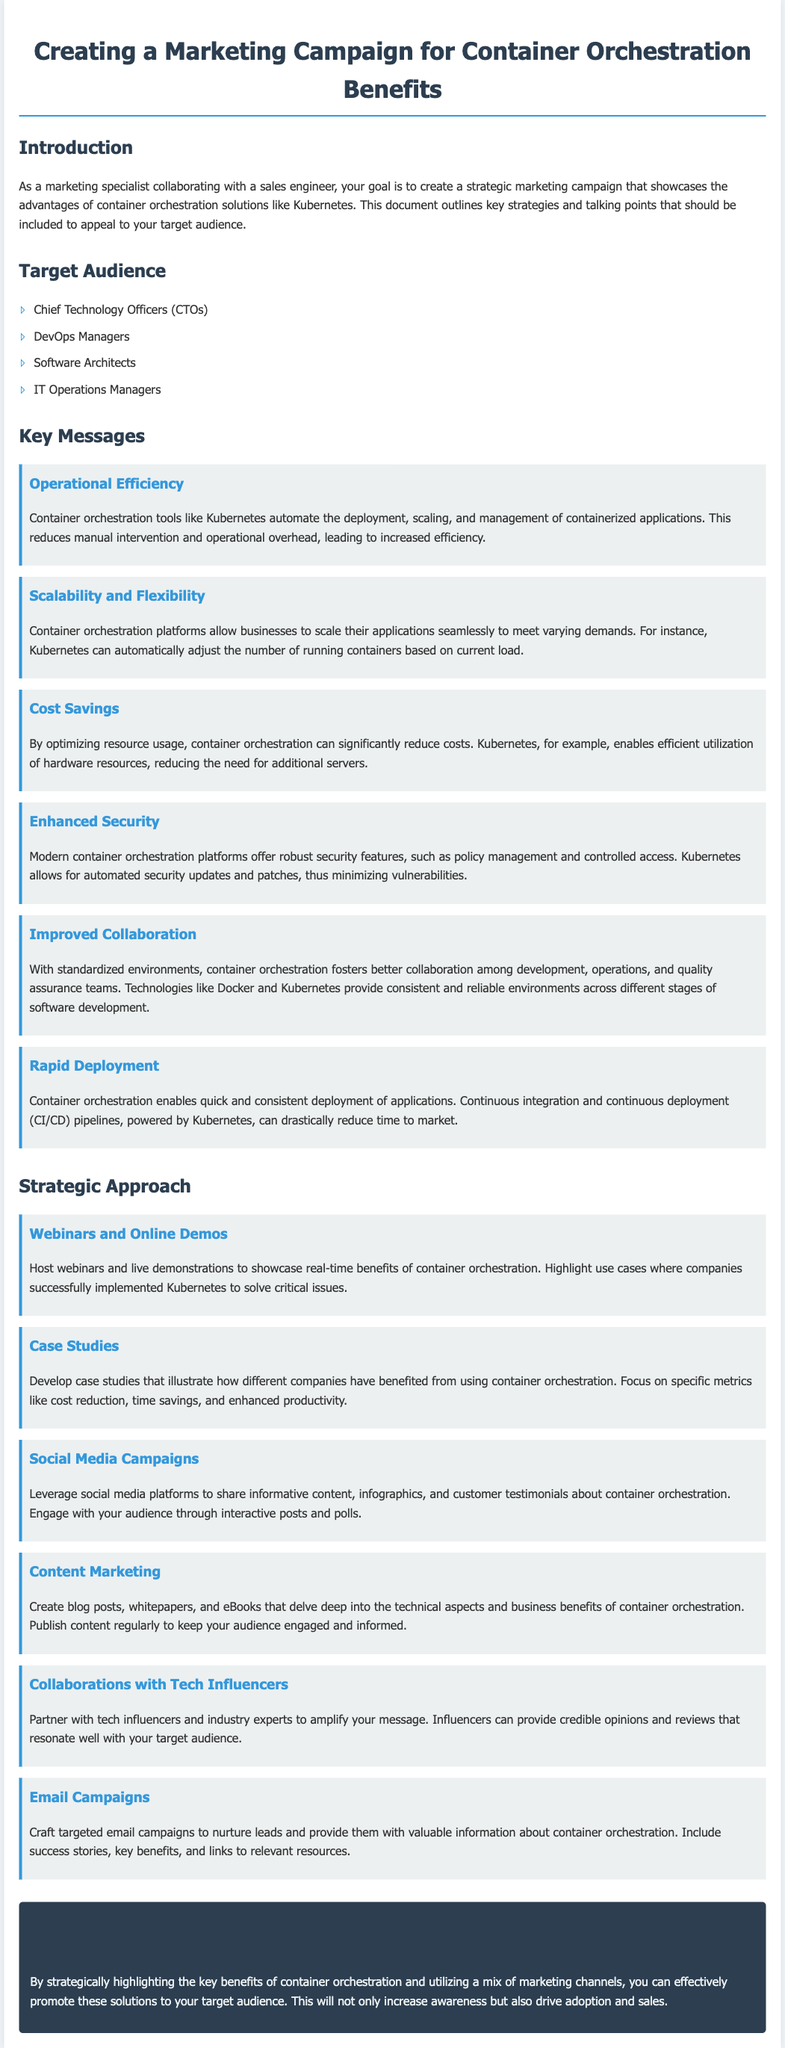what is the main goal of the marketing campaign? The main goal of the marketing campaign is to showcase the advantages of container orchestration solutions like Kubernetes.
Answer: showcase advantages who is one of the target audiences for the campaign? The document lists several target audiences, one of which is Chief Technology Officers (CTOs).
Answer: Chief Technology Officers (CTOs) name a key message related to cost benefits. The key message related to cost benefits highlights that container orchestration can significantly reduce costs by optimizing resource usage.
Answer: Cost Savings which platform is specifically mentioned as an example of container orchestration? Kubernetes is specifically mentioned as an example of container orchestration in the document.
Answer: Kubernetes what type of marketing strategy involves live demonstrations? Hosting webinars and live demonstrations is a type of marketing strategy mentioned in the document.
Answer: Webinars and Online Demos how many key messages are listed in the document? There are six key messages outlined in the document.
Answer: six what is one benefit of container orchestration mentioned? One benefit mentioned is operational efficiency through the automation of deployment and management.
Answer: Operational Efficiency which marketing strategy aims to nurture leads through emails? The strategy that aims to nurture leads through emails is described as targeted email campaigns.
Answer: Email Campaigns 